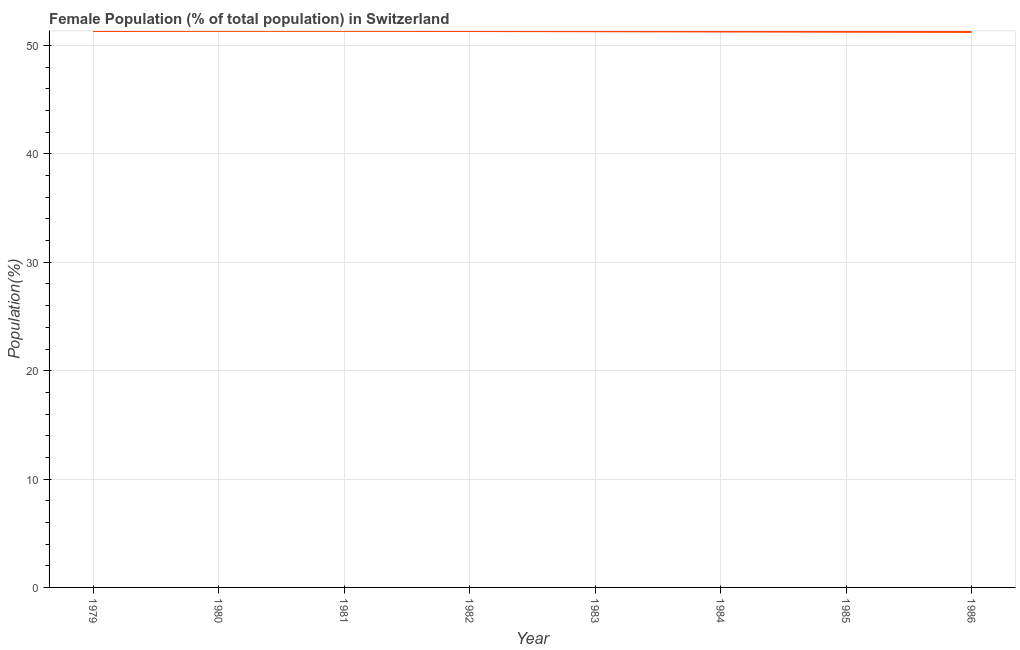What is the female population in 1985?
Keep it short and to the point. 51.28. Across all years, what is the maximum female population?
Ensure brevity in your answer.  51.36. Across all years, what is the minimum female population?
Your answer should be very brief. 51.26. What is the sum of the female population?
Your answer should be very brief. 410.56. What is the difference between the female population in 1979 and 1986?
Your answer should be compact. 0.09. What is the average female population per year?
Your answer should be compact. 51.32. What is the median female population?
Your answer should be very brief. 51.33. What is the ratio of the female population in 1980 to that in 1983?
Provide a short and direct response. 1. Is the female population in 1983 less than that in 1986?
Provide a succinct answer. No. Is the difference between the female population in 1980 and 1981 greater than the difference between any two years?
Offer a terse response. No. What is the difference between the highest and the second highest female population?
Offer a terse response. 0. What is the difference between the highest and the lowest female population?
Offer a very short reply. 0.1. Does the female population monotonically increase over the years?
Keep it short and to the point. No. Does the graph contain grids?
Make the answer very short. Yes. What is the title of the graph?
Keep it short and to the point. Female Population (% of total population) in Switzerland. What is the label or title of the X-axis?
Keep it short and to the point. Year. What is the label or title of the Y-axis?
Make the answer very short. Population(%). What is the Population(%) of 1979?
Offer a terse response. 51.34. What is the Population(%) of 1980?
Your answer should be compact. 51.36. What is the Population(%) of 1981?
Give a very brief answer. 51.36. What is the Population(%) in 1982?
Your answer should be compact. 51.34. What is the Population(%) of 1983?
Offer a very short reply. 51.32. What is the Population(%) of 1984?
Offer a terse response. 51.3. What is the Population(%) in 1985?
Keep it short and to the point. 51.28. What is the Population(%) of 1986?
Your answer should be very brief. 51.26. What is the difference between the Population(%) in 1979 and 1980?
Your answer should be compact. -0.01. What is the difference between the Population(%) in 1979 and 1981?
Make the answer very short. -0.01. What is the difference between the Population(%) in 1979 and 1982?
Provide a short and direct response. 0. What is the difference between the Population(%) in 1979 and 1983?
Make the answer very short. 0.02. What is the difference between the Population(%) in 1979 and 1984?
Make the answer very short. 0.04. What is the difference between the Population(%) in 1979 and 1985?
Offer a very short reply. 0.07. What is the difference between the Population(%) in 1979 and 1986?
Offer a terse response. 0.09. What is the difference between the Population(%) in 1980 and 1981?
Keep it short and to the point. 0. What is the difference between the Population(%) in 1980 and 1982?
Provide a succinct answer. 0.01. What is the difference between the Population(%) in 1980 and 1983?
Make the answer very short. 0.03. What is the difference between the Population(%) in 1980 and 1984?
Provide a succinct answer. 0.05. What is the difference between the Population(%) in 1980 and 1985?
Give a very brief answer. 0.08. What is the difference between the Population(%) in 1980 and 1986?
Make the answer very short. 0.1. What is the difference between the Population(%) in 1981 and 1982?
Provide a short and direct response. 0.01. What is the difference between the Population(%) in 1981 and 1983?
Your answer should be compact. 0.03. What is the difference between the Population(%) in 1981 and 1984?
Make the answer very short. 0.05. What is the difference between the Population(%) in 1981 and 1985?
Provide a succinct answer. 0.08. What is the difference between the Population(%) in 1981 and 1986?
Offer a very short reply. 0.1. What is the difference between the Population(%) in 1982 and 1983?
Keep it short and to the point. 0.02. What is the difference between the Population(%) in 1982 and 1984?
Give a very brief answer. 0.04. What is the difference between the Population(%) in 1982 and 1985?
Offer a very short reply. 0.06. What is the difference between the Population(%) in 1982 and 1986?
Your answer should be very brief. 0.09. What is the difference between the Population(%) in 1983 and 1984?
Give a very brief answer. 0.02. What is the difference between the Population(%) in 1983 and 1985?
Provide a short and direct response. 0.04. What is the difference between the Population(%) in 1983 and 1986?
Provide a succinct answer. 0.07. What is the difference between the Population(%) in 1984 and 1985?
Offer a terse response. 0.02. What is the difference between the Population(%) in 1984 and 1986?
Keep it short and to the point. 0.04. What is the difference between the Population(%) in 1985 and 1986?
Provide a succinct answer. 0.02. What is the ratio of the Population(%) in 1979 to that in 1980?
Offer a terse response. 1. What is the ratio of the Population(%) in 1979 to that in 1982?
Make the answer very short. 1. What is the ratio of the Population(%) in 1979 to that in 1983?
Your answer should be very brief. 1. What is the ratio of the Population(%) in 1979 to that in 1984?
Provide a succinct answer. 1. What is the ratio of the Population(%) in 1979 to that in 1985?
Your answer should be very brief. 1. What is the ratio of the Population(%) in 1980 to that in 1981?
Your answer should be very brief. 1. What is the ratio of the Population(%) in 1980 to that in 1982?
Keep it short and to the point. 1. What is the ratio of the Population(%) in 1980 to that in 1983?
Provide a succinct answer. 1. What is the ratio of the Population(%) in 1980 to that in 1985?
Provide a short and direct response. 1. What is the ratio of the Population(%) in 1980 to that in 1986?
Provide a short and direct response. 1. What is the ratio of the Population(%) in 1981 to that in 1983?
Your answer should be compact. 1. What is the ratio of the Population(%) in 1981 to that in 1985?
Your answer should be compact. 1. What is the ratio of the Population(%) in 1982 to that in 1984?
Provide a short and direct response. 1. What is the ratio of the Population(%) in 1982 to that in 1985?
Keep it short and to the point. 1. What is the ratio of the Population(%) in 1984 to that in 1985?
Keep it short and to the point. 1. What is the ratio of the Population(%) in 1984 to that in 1986?
Your response must be concise. 1. What is the ratio of the Population(%) in 1985 to that in 1986?
Give a very brief answer. 1. 